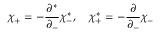<formula> <loc_0><loc_0><loc_500><loc_500>\chi _ { + } = - \frac { \partial ^ { * } } { \partial _ { - } } \chi _ { - } ^ { * } , \quad \chi _ { + } ^ { * } = - \frac { \partial } { \partial _ { - } } \chi _ { - }</formula> 